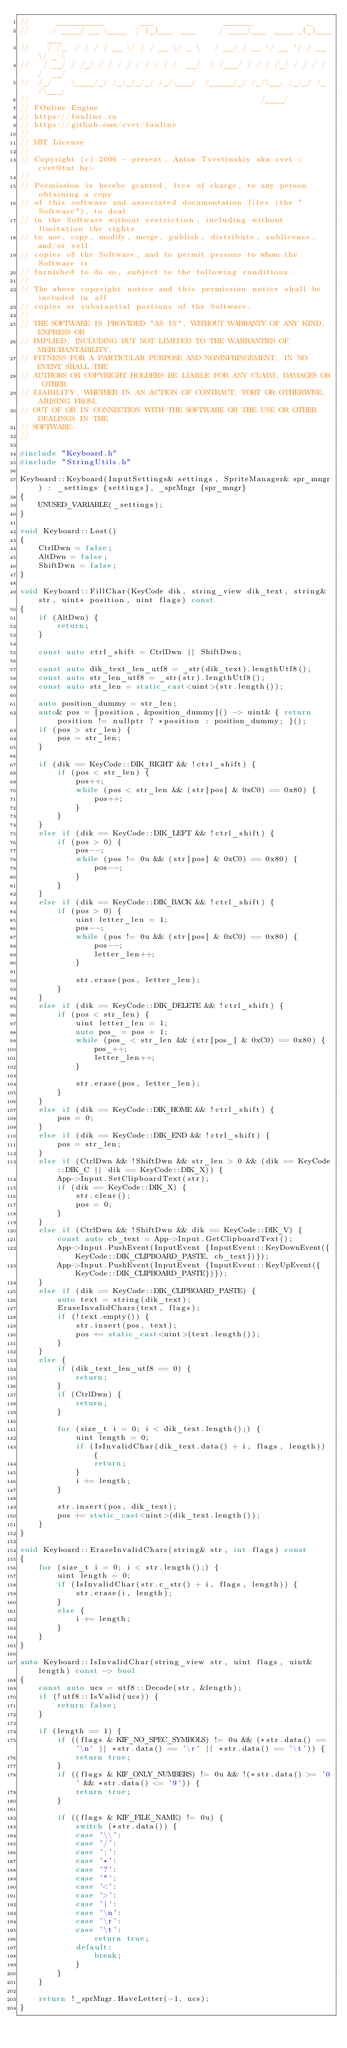<code> <loc_0><loc_0><loc_500><loc_500><_C++_>//      __________        ___               ______            _
//     / ____/ __ \____  / (_)___  ___     / ____/___  ____ _(_)___  ___
//    / /_  / / / / __ \/ / / __ \/ _ \   / __/ / __ \/ __ `/ / __ \/ _ \
//   / __/ / /_/ / / / / / / / / /  __/  / /___/ / / / /_/ / / / / /  __/
//  /_/    \____/_/ /_/_/_/_/ /_/\___/  /_____/_/ /_/\__, /_/_/ /_/\___/
//                                                  /____/
// FOnline Engine
// https://fonline.ru
// https://github.com/cvet/fonline
//
// MIT License
//
// Copyright (c) 2006 - present, Anton Tsvetinskiy aka cvet <cvet@tut.by>
//
// Permission is hereby granted, free of charge, to any person obtaining a copy
// of this software and associated documentation files (the "Software"), to deal
// in the Software without restriction, including without limitation the rights
// to use, copy, modify, merge, publish, distribute, sublicense, and/or sell
// copies of the Software, and to permit persons to whom the Software is
// furnished to do so, subject to the following conditions:
//
// The above copyright notice and this permission notice shall be included in all
// copies or substantial portions of the Software.
//
// THE SOFTWARE IS PROVIDED "AS IS", WITHOUT WARRANTY OF ANY KIND, EXPRESS OR
// IMPLIED, INCLUDING BUT NOT LIMITED TO THE WARRANTIES OF MERCHANTABILITY,
// FITNESS FOR A PARTICULAR PURPOSE AND NONINFRINGEMENT. IN NO EVENT SHALL THE
// AUTHORS OR COPYRIGHT HOLDERS BE LIABLE FOR ANY CLAIM, DAMAGES OR OTHER
// LIABILITY, WHETHER IN AN ACTION OF CONTRACT, TORT OR OTHERWISE, ARISING FROM,
// OUT OF OR IN CONNECTION WITH THE SOFTWARE OR THE USE OR OTHER DEALINGS IN THE
// SOFTWARE.
//

#include "Keyboard.h"
#include "StringUtils.h"

Keyboard::Keyboard(InputSettings& settings, SpriteManager& spr_mngr) : _settings {settings}, _sprMngr {spr_mngr}
{
    UNUSED_VARIABLE(_settings);
}

void Keyboard::Lost()
{
    CtrlDwn = false;
    AltDwn = false;
    ShiftDwn = false;
}

void Keyboard::FillChar(KeyCode dik, string_view dik_text, string& str, uint* position, uint flags) const
{
    if (AltDwn) {
        return;
    }

    const auto ctrl_shift = CtrlDwn || ShiftDwn;

    const auto dik_text_len_utf8 = _str(dik_text).lengthUtf8();
    const auto str_len_utf8 = _str(str).lengthUtf8();
    const auto str_len = static_cast<uint>(str.length());

    auto position_dummy = str_len;
    auto& pos = [position, &position_dummy]() -> uint& { return position != nullptr ? *position : position_dummy; }();
    if (pos > str_len) {
        pos = str_len;
    }

    if (dik == KeyCode::DIK_RIGHT && !ctrl_shift) {
        if (pos < str_len) {
            pos++;
            while (pos < str_len && (str[pos] & 0xC0) == 0x80) {
                pos++;
            }
        }
    }
    else if (dik == KeyCode::DIK_LEFT && !ctrl_shift) {
        if (pos > 0) {
            pos--;
            while (pos != 0u && (str[pos] & 0xC0) == 0x80) {
                pos--;
            }
        }
    }
    else if (dik == KeyCode::DIK_BACK && !ctrl_shift) {
        if (pos > 0) {
            uint letter_len = 1;
            pos--;
            while (pos != 0u && (str[pos] & 0xC0) == 0x80) {
                pos--;
                letter_len++;
            }

            str.erase(pos, letter_len);
        }
    }
    else if (dik == KeyCode::DIK_DELETE && !ctrl_shift) {
        if (pos < str_len) {
            uint letter_len = 1;
            auto pos_ = pos + 1;
            while (pos_ < str_len && (str[pos_] & 0xC0) == 0x80) {
                pos_++;
                letter_len++;
            }

            str.erase(pos, letter_len);
        }
    }
    else if (dik == KeyCode::DIK_HOME && !ctrl_shift) {
        pos = 0;
    }
    else if (dik == KeyCode::DIK_END && !ctrl_shift) {
        pos = str_len;
    }
    else if (CtrlDwn && !ShiftDwn && str_len > 0 && (dik == KeyCode::DIK_C || dik == KeyCode::DIK_X)) {
        App->Input.SetClipboardText(str);
        if (dik == KeyCode::DIK_X) {
            str.clear();
            pos = 0;
        }
    }
    else if (CtrlDwn && !ShiftDwn && dik == KeyCode::DIK_V) {
        const auto cb_text = App->Input.GetClipboardText();
        App->Input.PushEvent(InputEvent {InputEvent::KeyDownEvent({KeyCode::DIK_CLIPBOARD_PASTE, cb_text})});
        App->Input.PushEvent(InputEvent {InputEvent::KeyUpEvent({KeyCode::DIK_CLIPBOARD_PASTE})});
    }
    else if (dik == KeyCode::DIK_CLIPBOARD_PASTE) {
        auto text = string(dik_text);
        EraseInvalidChars(text, flags);
        if (!text.empty()) {
            str.insert(pos, text);
            pos += static_cast<uint>(text.length());
        }
    }
    else {
        if (dik_text_len_utf8 == 0) {
            return;
        }
        if (CtrlDwn) {
            return;
        }

        for (size_t i = 0; i < dik_text.length();) {
            uint length = 0;
            if (IsInvalidChar(dik_text.data() + i, flags, length)) {
                return;
            }
            i += length;
        }

        str.insert(pos, dik_text);
        pos += static_cast<uint>(dik_text.length());
    }
}

void Keyboard::EraseInvalidChars(string& str, int flags) const
{
    for (size_t i = 0; i < str.length();) {
        uint length = 0;
        if (IsInvalidChar(str.c_str() + i, flags, length)) {
            str.erase(i, length);
        }
        else {
            i += length;
        }
    }
}

auto Keyboard::IsInvalidChar(string_view str, uint flags, uint& length) const -> bool
{
    const auto ucs = utf8::Decode(str, &length);
    if (!utf8::IsValid(ucs)) {
        return false;
    }

    if (length == 1) {
        if ((flags & KIF_NO_SPEC_SYMBOLS) != 0u && (*str.data() == '\n' || *str.data() == '\r' || *str.data() == '\t')) {
            return true;
        }
        if ((flags & KIF_ONLY_NUMBERS) != 0u && !(*str.data() >= '0' && *str.data() <= '9')) {
            return true;
        }

        if ((flags & KIF_FILE_NAME) != 0u) {
            switch (*str.data()) {
            case '\\':
            case '/':
            case ':':
            case '*':
            case '?':
            case '"':
            case '<':
            case '>':
            case '|':
            case '\n':
            case '\r':
            case '\t':
                return true;
            default:
                break;
            }
        }
    }

    return !_sprMngr.HaveLetter(-1, ucs);
}
</code> 